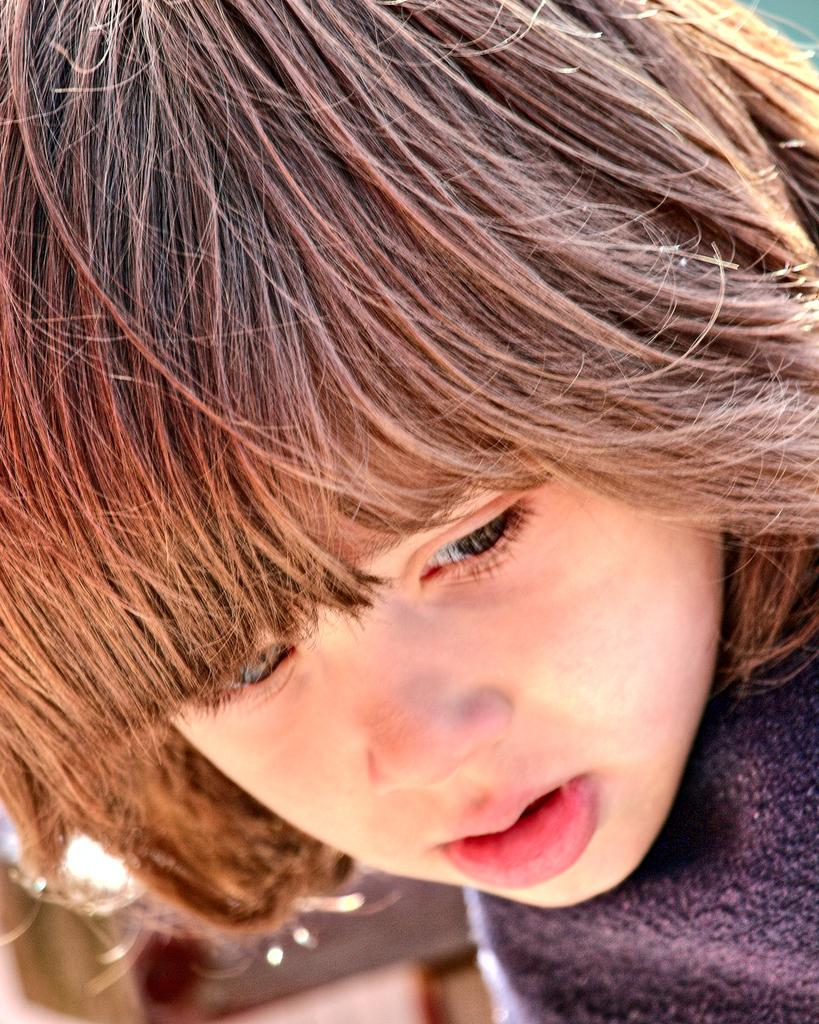What is the main subject of the image? The main subject of the image is a kid. Can you describe the kid's appearance? The kid has long hair and is wearing a blue color dress. What type of loaf is the kid holding in the image? There is no loaf present in the image; the kid is not holding anything. 